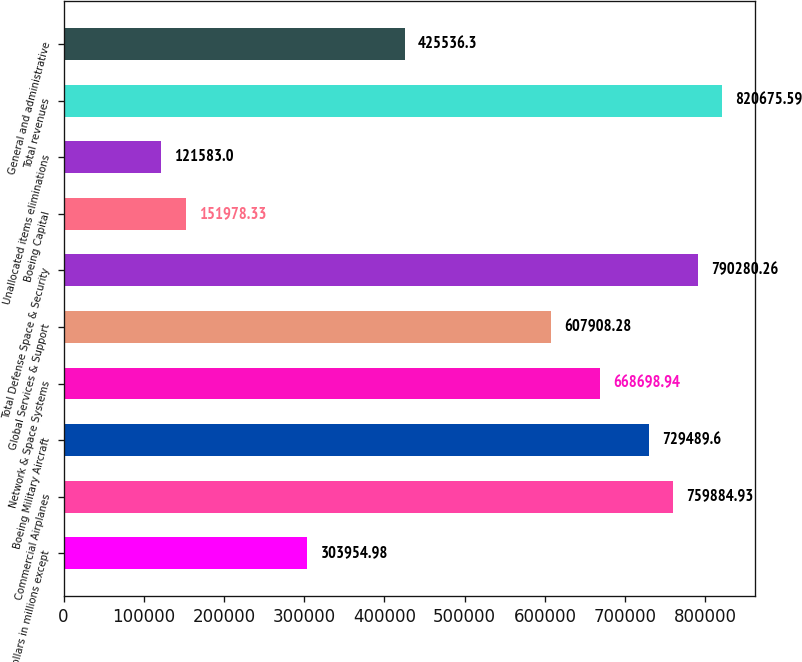Convert chart. <chart><loc_0><loc_0><loc_500><loc_500><bar_chart><fcel>(Dollars in millions except<fcel>Commercial Airplanes<fcel>Boeing Military Aircraft<fcel>Network & Space Systems<fcel>Global Services & Support<fcel>Total Defense Space & Security<fcel>Boeing Capital<fcel>Unallocated items eliminations<fcel>Total revenues<fcel>General and administrative<nl><fcel>303955<fcel>759885<fcel>729490<fcel>668699<fcel>607908<fcel>790280<fcel>151978<fcel>121583<fcel>820676<fcel>425536<nl></chart> 